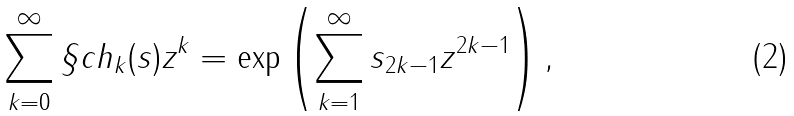<formula> <loc_0><loc_0><loc_500><loc_500>\sum _ { k = 0 } ^ { \infty } \S c h _ { k } ( s ) z ^ { k } = \exp \left ( \sum _ { k = 1 } ^ { \infty } s _ { 2 k - 1 } z ^ { 2 k - 1 } \right ) ,</formula> 